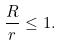Convert formula to latex. <formula><loc_0><loc_0><loc_500><loc_500>\frac { R } { r } \leq 1 .</formula> 